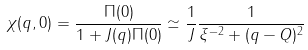Convert formula to latex. <formula><loc_0><loc_0><loc_500><loc_500>\chi ( q , 0 ) = \frac { \Pi ( 0 ) } { 1 + J ( q ) \Pi ( 0 ) } \simeq \frac { 1 } { J } \frac { 1 } { \xi ^ { - 2 } + ( q - Q ) ^ { 2 } }</formula> 